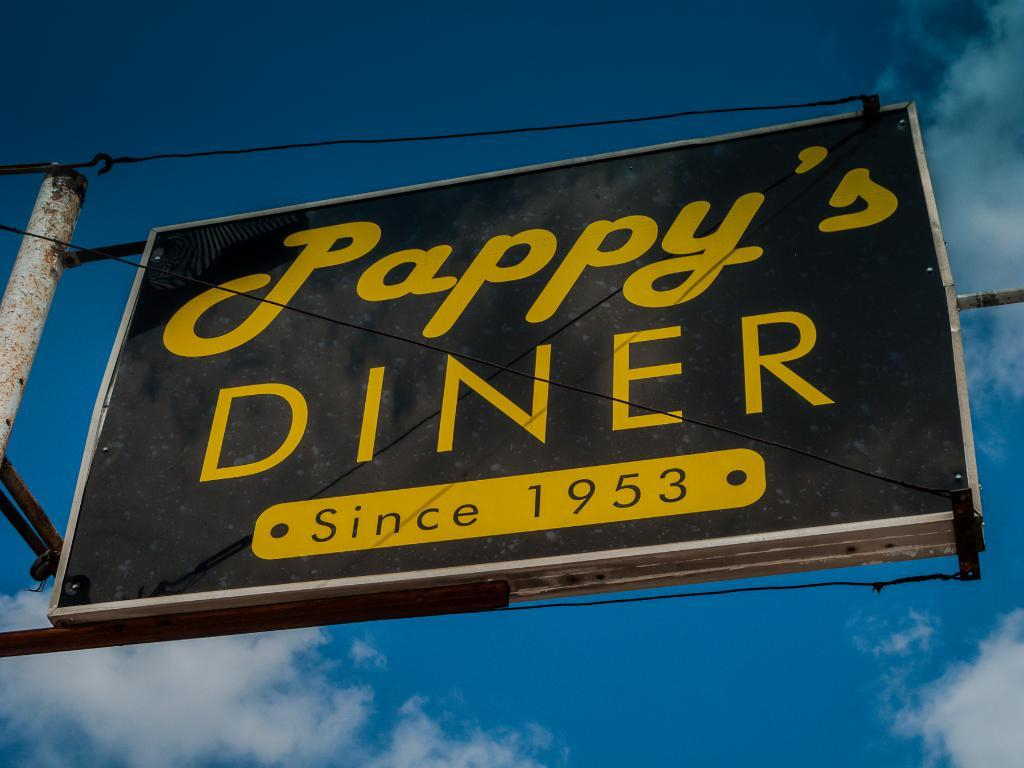What is the main object in the middle of the image? There is a black color name board in the middle of the image}. What information is displayed on the name board? The name board has a name and a year on it. What else can be seen near the name board? There are wires near the name board. What is present in the left corner of the image? There is a pole in the left corner of the image. What type of love can be seen expressed on the name board? There is no love expressed on the name board; it only displays a name and a year. What tool is being used by the passenger in the image? There is no passenger or tool present in the image. 